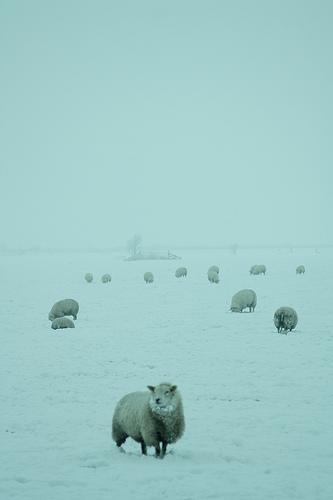How many sheep are in the forefront?
Give a very brief answer. 1. How many sheep faces are to be seen in the picture?
Give a very brief answer. 1. 